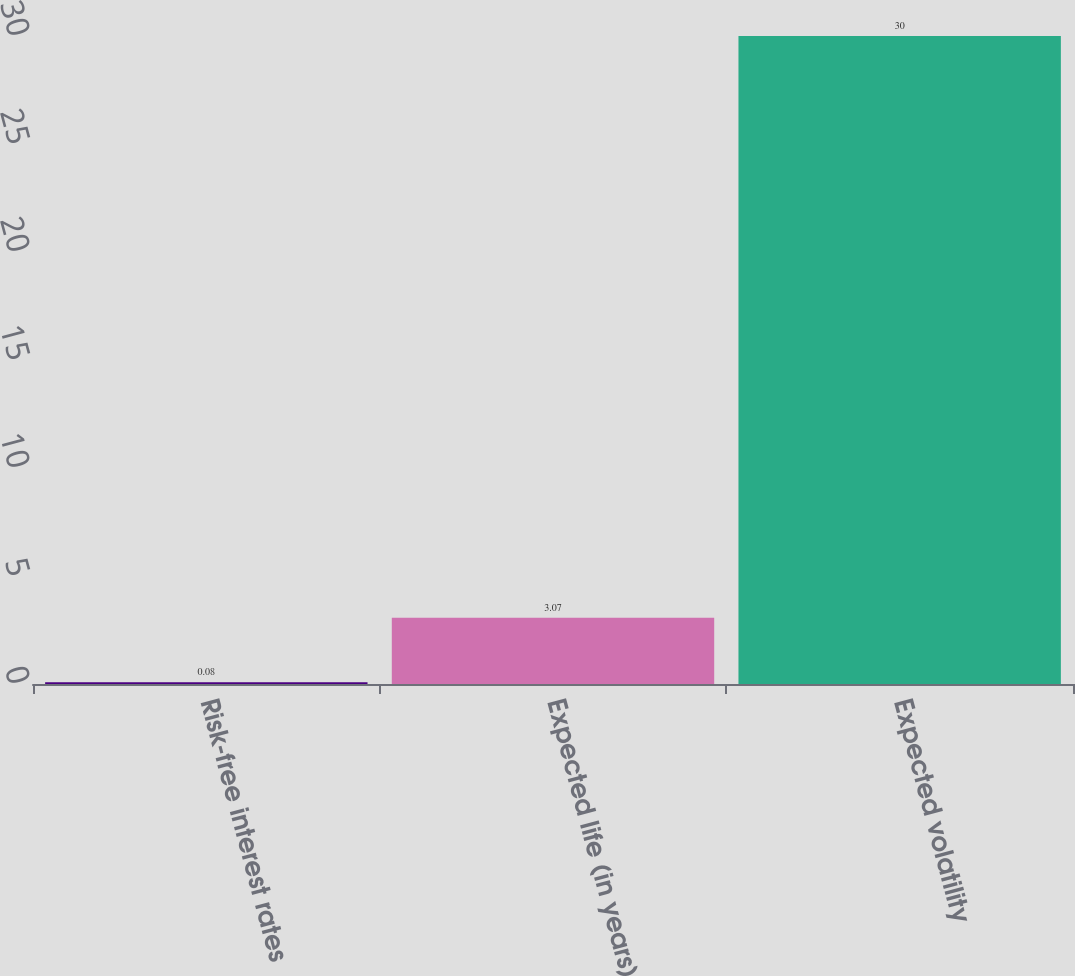Convert chart to OTSL. <chart><loc_0><loc_0><loc_500><loc_500><bar_chart><fcel>Risk-free interest rates<fcel>Expected life (in years)<fcel>Expected volatility<nl><fcel>0.08<fcel>3.07<fcel>30<nl></chart> 